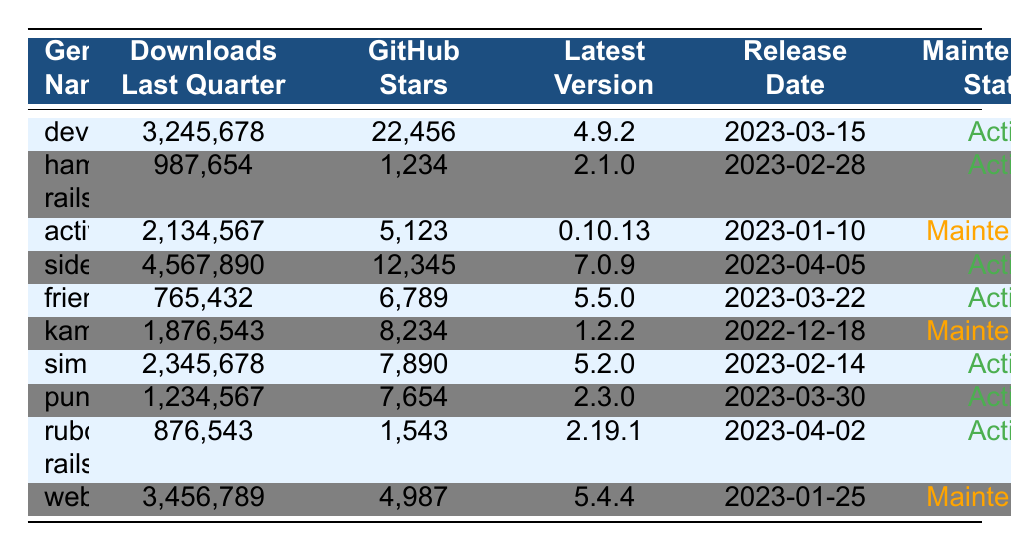What is the most downloaded gem in the last quarter? The table shows the "Downloads Last Quarter" values for each gem. The highest number is 4,567,890 for the gem "sidekiq."
Answer: sidekiq How many GitHub stars does "devise" have? The table lists "devise" with 22,456 GitHub stars directly under its name.
Answer: 22,456 What is the latest version of the "friendly_id" gem? The latest version of "friendly_id" is listed as "5.5.0" in the respective column.
Answer: 5.5.0 List the maintenance status of "active_model_serializers." The table indicates that "active_model_serializers" has a maintenance status marked as "Maintenance."
Answer: Maintenance Which gem was released most recently? By examining the "Release Date" column, "sidekiq" has the latest date of 2023-04-05, showing it is the most recently released gem.
Answer: sidekiq What is the difference in downloads between "simple_form" and "rubocop-rails"? "simple_form" has 2,345,678 downloads, while "rubocop-rails" has 876,543. The difference is 2,345,678 - 876,543 = 1,469,135.
Answer: 1,469,135 How many gems have an active maintenance status? By scanning the "Maintenance Status" column, we see that four gems—"devise," "haml-rails," "sidekiq," and "friendly_id"—are listed as "Active."
Answer: 6 What is the average number of downloads for all gems that are in maintenance? For the gems with "Maintenance" status: "active_model_serializers" has 2,134,567 downloads, "kaminari" has 1,876,543, and "webpacker" has 3,456,789. Total downloads = 2,134,567 + 1,876,543 + 876,543 = 4,888,653. The average is 4,888,653 / 3 = 1,629,551.
Answer: 1,629,551 Is there a gem with the highest GitHub stars that is in maintenance? The table shows that "active_model_serializers" has 5,123 GitHub stars and is in maintenance, which is the highest among maintenance gems.
Answer: Yes Which gem has the least number of downloads, and what is its download count? The table shows "haml-rails" as having the least downloads at 987,654.
Answer: haml-rails, 987,654 